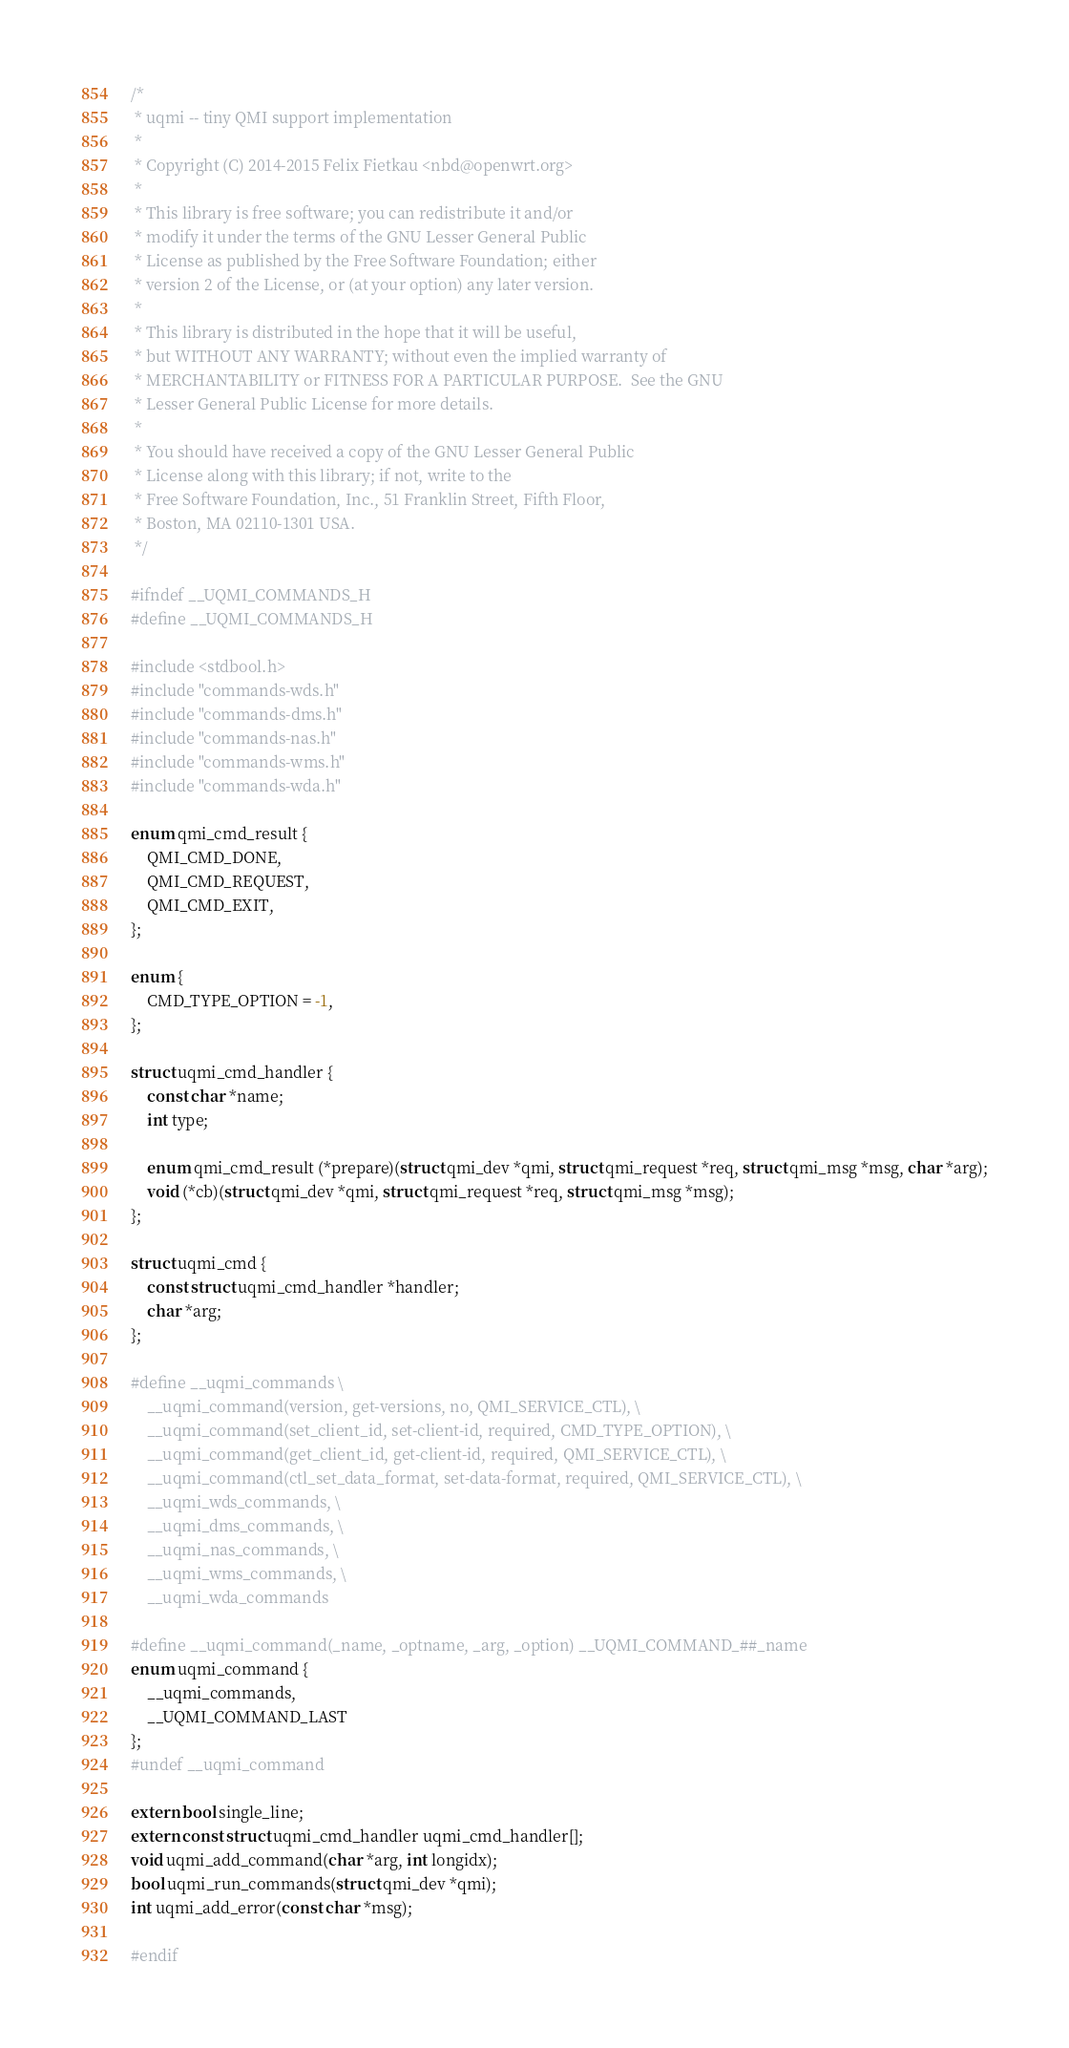<code> <loc_0><loc_0><loc_500><loc_500><_C_>/*
 * uqmi -- tiny QMI support implementation
 *
 * Copyright (C) 2014-2015 Felix Fietkau <nbd@openwrt.org>
 *
 * This library is free software; you can redistribute it and/or
 * modify it under the terms of the GNU Lesser General Public
 * License as published by the Free Software Foundation; either
 * version 2 of the License, or (at your option) any later version.
 *
 * This library is distributed in the hope that it will be useful,
 * but WITHOUT ANY WARRANTY; without even the implied warranty of
 * MERCHANTABILITY or FITNESS FOR A PARTICULAR PURPOSE.  See the GNU
 * Lesser General Public License for more details.
 *
 * You should have received a copy of the GNU Lesser General Public
 * License along with this library; if not, write to the
 * Free Software Foundation, Inc., 51 Franklin Street, Fifth Floor,
 * Boston, MA 02110-1301 USA.
 */

#ifndef __UQMI_COMMANDS_H
#define __UQMI_COMMANDS_H

#include <stdbool.h>
#include "commands-wds.h"
#include "commands-dms.h"
#include "commands-nas.h"
#include "commands-wms.h"
#include "commands-wda.h"

enum qmi_cmd_result {
	QMI_CMD_DONE,
	QMI_CMD_REQUEST,
	QMI_CMD_EXIT,
};

enum {
	CMD_TYPE_OPTION = -1,
};

struct uqmi_cmd_handler {
	const char *name;
	int type;

	enum qmi_cmd_result (*prepare)(struct qmi_dev *qmi, struct qmi_request *req, struct qmi_msg *msg, char *arg);
	void (*cb)(struct qmi_dev *qmi, struct qmi_request *req, struct qmi_msg *msg);
};

struct uqmi_cmd {
	const struct uqmi_cmd_handler *handler;
	char *arg;
};

#define __uqmi_commands \
	__uqmi_command(version, get-versions, no, QMI_SERVICE_CTL), \
	__uqmi_command(set_client_id, set-client-id, required, CMD_TYPE_OPTION), \
	__uqmi_command(get_client_id, get-client-id, required, QMI_SERVICE_CTL), \
	__uqmi_command(ctl_set_data_format, set-data-format, required, QMI_SERVICE_CTL), \
	__uqmi_wds_commands, \
	__uqmi_dms_commands, \
	__uqmi_nas_commands, \
	__uqmi_wms_commands, \
	__uqmi_wda_commands

#define __uqmi_command(_name, _optname, _arg, _option) __UQMI_COMMAND_##_name
enum uqmi_command {
	__uqmi_commands,
	__UQMI_COMMAND_LAST
};
#undef __uqmi_command

extern bool single_line;
extern const struct uqmi_cmd_handler uqmi_cmd_handler[];
void uqmi_add_command(char *arg, int longidx);
bool uqmi_run_commands(struct qmi_dev *qmi);
int uqmi_add_error(const char *msg);

#endif
</code> 